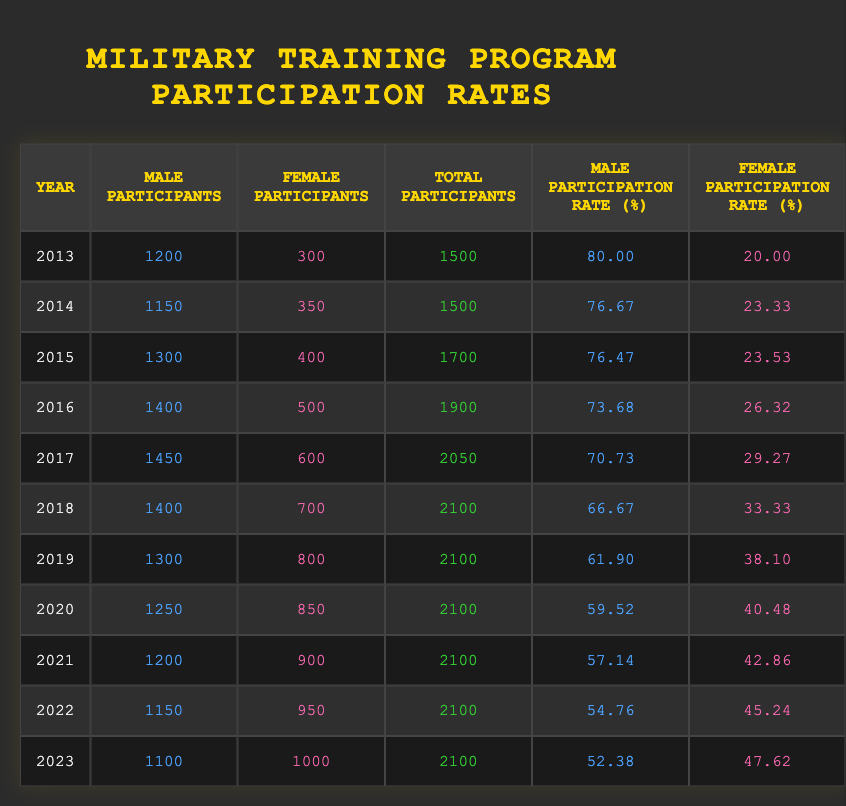What was the male participation rate in 2020? In the 2020 row, the male participation rate is listed directly in the table as 59.52%.
Answer: 59.52 How many female participants were there in 2018? Referring to the row for 2018, the number of female participants is given as 700.
Answer: 700 What was the total number of participants in 2015? The table shows that in 2015, the total number of participants is 1700.
Answer: 1700 Which year saw the highest female participation rate and what was it? Looking at the female participation rates over the years, the highest rate is in 2023 at 47.62%.
Answer: 47.62 in 2023 What is the difference in male participants between 2013 and 2023? Male participants in 2013 were 1200, and in 2023 it is 1100. The difference is 1200 - 1100 = 100.
Answer: 100 Was the male participation rate lower in 2021 than in 2020? From the table, the male participation rate in 2021 is 57.14%, and in 2020 it is 59.52%. Since 57.14 is less than 59.52, the answer is yes.
Answer: Yes What is the average female participation rate over the decade? To find the average, sum up the female participation rates (20 + 23.33 + 23.53 + 26.32 + 29.27 + 33.33 + 38.10 + 40.48 + 42.86 + 45.24 + 47.62), which totals to  392.16. Since there are 11 years, divide by 11. The average is approximately 35.65.
Answer: 35.65 How many total participants were there in the year with the lowest male participation rate? The lowest male participation rate was in 2023 at 52.38%. In that year, the total number of participants is 2100.
Answer: 2100 Is it true that the number of female participants increased every year from 2013 to 2023? Checking each year, the female participants increased every year: 300 (2013), 350 (2014), 400 (2015), 500 (2016), 600 (2017), 700 (2018), 800 (2019), 850 (2020), 900 (2021), 950 (2022), and 1000 (2023). So the statement is true.
Answer: Yes 